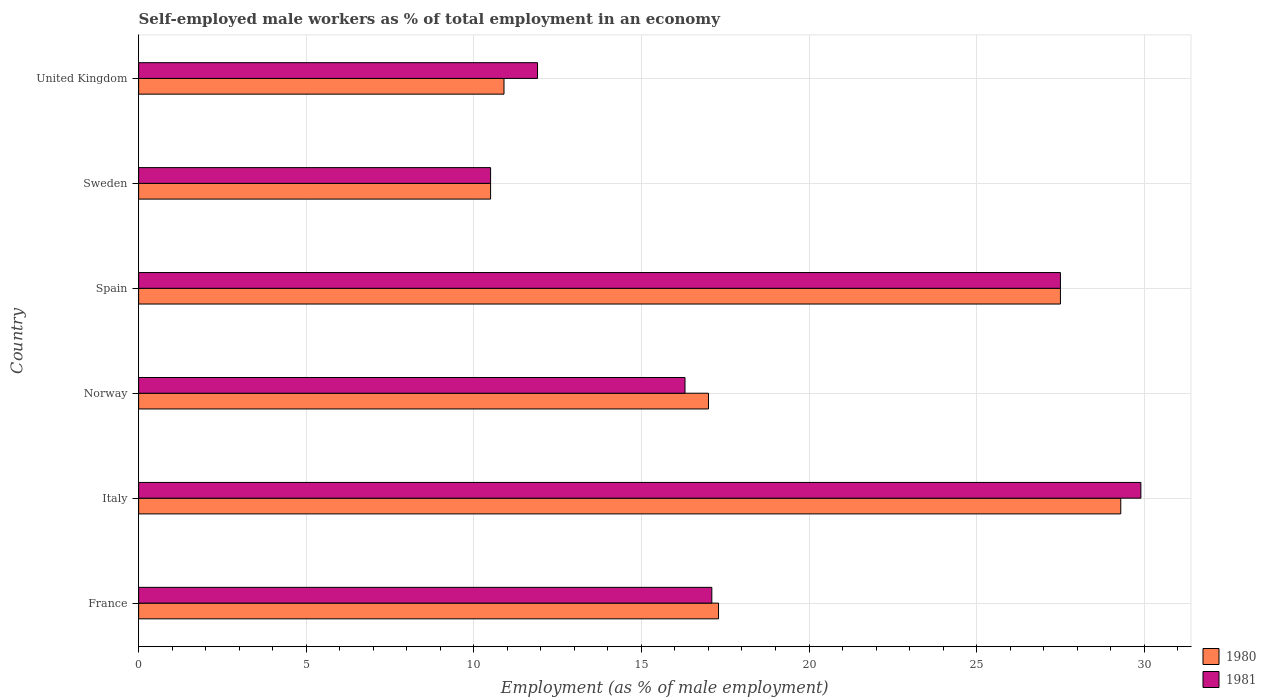How many different coloured bars are there?
Make the answer very short. 2. How many groups of bars are there?
Keep it short and to the point. 6. How many bars are there on the 5th tick from the top?
Keep it short and to the point. 2. What is the label of the 5th group of bars from the top?
Make the answer very short. Italy. What is the percentage of self-employed male workers in 1981 in Norway?
Offer a terse response. 16.3. Across all countries, what is the maximum percentage of self-employed male workers in 1980?
Your response must be concise. 29.3. In which country was the percentage of self-employed male workers in 1981 maximum?
Your answer should be very brief. Italy. What is the total percentage of self-employed male workers in 1980 in the graph?
Provide a succinct answer. 112.5. What is the difference between the percentage of self-employed male workers in 1980 in Norway and that in United Kingdom?
Offer a terse response. 6.1. What is the difference between the percentage of self-employed male workers in 1980 in Spain and the percentage of self-employed male workers in 1981 in France?
Give a very brief answer. 10.4. What is the average percentage of self-employed male workers in 1980 per country?
Provide a succinct answer. 18.75. What is the difference between the percentage of self-employed male workers in 1981 and percentage of self-employed male workers in 1980 in Spain?
Provide a succinct answer. 0. What is the ratio of the percentage of self-employed male workers in 1980 in France to that in Spain?
Offer a very short reply. 0.63. Is the difference between the percentage of self-employed male workers in 1981 in Norway and Sweden greater than the difference between the percentage of self-employed male workers in 1980 in Norway and Sweden?
Ensure brevity in your answer.  No. What is the difference between the highest and the second highest percentage of self-employed male workers in 1981?
Give a very brief answer. 2.4. What is the difference between the highest and the lowest percentage of self-employed male workers in 1981?
Provide a short and direct response. 19.4. Is the sum of the percentage of self-employed male workers in 1981 in Norway and Spain greater than the maximum percentage of self-employed male workers in 1980 across all countries?
Provide a short and direct response. Yes. What does the 1st bar from the bottom in Norway represents?
Your response must be concise. 1980. Are the values on the major ticks of X-axis written in scientific E-notation?
Your answer should be very brief. No. Does the graph contain grids?
Keep it short and to the point. Yes. How many legend labels are there?
Your answer should be very brief. 2. What is the title of the graph?
Your answer should be very brief. Self-employed male workers as % of total employment in an economy. What is the label or title of the X-axis?
Ensure brevity in your answer.  Employment (as % of male employment). What is the Employment (as % of male employment) of 1980 in France?
Provide a succinct answer. 17.3. What is the Employment (as % of male employment) of 1981 in France?
Your answer should be very brief. 17.1. What is the Employment (as % of male employment) in 1980 in Italy?
Give a very brief answer. 29.3. What is the Employment (as % of male employment) in 1981 in Italy?
Give a very brief answer. 29.9. What is the Employment (as % of male employment) in 1981 in Norway?
Offer a very short reply. 16.3. What is the Employment (as % of male employment) of 1980 in Spain?
Offer a terse response. 27.5. What is the Employment (as % of male employment) of 1981 in Spain?
Your response must be concise. 27.5. What is the Employment (as % of male employment) of 1981 in Sweden?
Your answer should be very brief. 10.5. What is the Employment (as % of male employment) in 1980 in United Kingdom?
Keep it short and to the point. 10.9. What is the Employment (as % of male employment) in 1981 in United Kingdom?
Offer a very short reply. 11.9. Across all countries, what is the maximum Employment (as % of male employment) of 1980?
Ensure brevity in your answer.  29.3. Across all countries, what is the maximum Employment (as % of male employment) of 1981?
Ensure brevity in your answer.  29.9. Across all countries, what is the minimum Employment (as % of male employment) in 1980?
Your response must be concise. 10.5. Across all countries, what is the minimum Employment (as % of male employment) of 1981?
Offer a terse response. 10.5. What is the total Employment (as % of male employment) of 1980 in the graph?
Your answer should be compact. 112.5. What is the total Employment (as % of male employment) of 1981 in the graph?
Provide a short and direct response. 113.2. What is the difference between the Employment (as % of male employment) of 1980 in France and that in Italy?
Ensure brevity in your answer.  -12. What is the difference between the Employment (as % of male employment) in 1981 in France and that in Italy?
Keep it short and to the point. -12.8. What is the difference between the Employment (as % of male employment) in 1980 in France and that in Norway?
Make the answer very short. 0.3. What is the difference between the Employment (as % of male employment) in 1981 in France and that in Norway?
Your answer should be compact. 0.8. What is the difference between the Employment (as % of male employment) of 1981 in France and that in Spain?
Offer a terse response. -10.4. What is the difference between the Employment (as % of male employment) in 1981 in France and that in United Kingdom?
Your answer should be very brief. 5.2. What is the difference between the Employment (as % of male employment) of 1981 in Italy and that in Norway?
Provide a succinct answer. 13.6. What is the difference between the Employment (as % of male employment) of 1980 in Italy and that in Spain?
Offer a terse response. 1.8. What is the difference between the Employment (as % of male employment) in 1981 in Italy and that in Spain?
Your answer should be compact. 2.4. What is the difference between the Employment (as % of male employment) in 1981 in Italy and that in Sweden?
Offer a terse response. 19.4. What is the difference between the Employment (as % of male employment) of 1980 in Italy and that in United Kingdom?
Provide a succinct answer. 18.4. What is the difference between the Employment (as % of male employment) in 1981 in Italy and that in United Kingdom?
Offer a terse response. 18. What is the difference between the Employment (as % of male employment) of 1981 in Norway and that in Spain?
Make the answer very short. -11.2. What is the difference between the Employment (as % of male employment) of 1980 in Norway and that in Sweden?
Your answer should be compact. 6.5. What is the difference between the Employment (as % of male employment) in 1981 in Norway and that in United Kingdom?
Make the answer very short. 4.4. What is the difference between the Employment (as % of male employment) of 1980 in Spain and that in United Kingdom?
Your response must be concise. 16.6. What is the difference between the Employment (as % of male employment) of 1980 in Sweden and that in United Kingdom?
Your answer should be compact. -0.4. What is the difference between the Employment (as % of male employment) in 1980 in France and the Employment (as % of male employment) in 1981 in Norway?
Your answer should be very brief. 1. What is the difference between the Employment (as % of male employment) in 1980 in France and the Employment (as % of male employment) in 1981 in Spain?
Offer a terse response. -10.2. What is the difference between the Employment (as % of male employment) of 1980 in Italy and the Employment (as % of male employment) of 1981 in Spain?
Keep it short and to the point. 1.8. What is the difference between the Employment (as % of male employment) in 1980 in Norway and the Employment (as % of male employment) in 1981 in Spain?
Offer a terse response. -10.5. What is the difference between the Employment (as % of male employment) in 1980 in Norway and the Employment (as % of male employment) in 1981 in Sweden?
Provide a short and direct response. 6.5. What is the difference between the Employment (as % of male employment) of 1980 in Norway and the Employment (as % of male employment) of 1981 in United Kingdom?
Make the answer very short. 5.1. What is the difference between the Employment (as % of male employment) in 1980 in Spain and the Employment (as % of male employment) in 1981 in Sweden?
Make the answer very short. 17. What is the difference between the Employment (as % of male employment) in 1980 in Spain and the Employment (as % of male employment) in 1981 in United Kingdom?
Make the answer very short. 15.6. What is the difference between the Employment (as % of male employment) in 1980 in Sweden and the Employment (as % of male employment) in 1981 in United Kingdom?
Offer a very short reply. -1.4. What is the average Employment (as % of male employment) of 1980 per country?
Your answer should be compact. 18.75. What is the average Employment (as % of male employment) in 1981 per country?
Provide a short and direct response. 18.87. What is the difference between the Employment (as % of male employment) of 1980 and Employment (as % of male employment) of 1981 in Norway?
Your response must be concise. 0.7. What is the difference between the Employment (as % of male employment) in 1980 and Employment (as % of male employment) in 1981 in Sweden?
Provide a succinct answer. 0. What is the difference between the Employment (as % of male employment) of 1980 and Employment (as % of male employment) of 1981 in United Kingdom?
Ensure brevity in your answer.  -1. What is the ratio of the Employment (as % of male employment) of 1980 in France to that in Italy?
Your response must be concise. 0.59. What is the ratio of the Employment (as % of male employment) in 1981 in France to that in Italy?
Your response must be concise. 0.57. What is the ratio of the Employment (as % of male employment) of 1980 in France to that in Norway?
Your response must be concise. 1.02. What is the ratio of the Employment (as % of male employment) in 1981 in France to that in Norway?
Make the answer very short. 1.05. What is the ratio of the Employment (as % of male employment) of 1980 in France to that in Spain?
Offer a very short reply. 0.63. What is the ratio of the Employment (as % of male employment) in 1981 in France to that in Spain?
Your answer should be very brief. 0.62. What is the ratio of the Employment (as % of male employment) of 1980 in France to that in Sweden?
Offer a very short reply. 1.65. What is the ratio of the Employment (as % of male employment) of 1981 in France to that in Sweden?
Your answer should be very brief. 1.63. What is the ratio of the Employment (as % of male employment) in 1980 in France to that in United Kingdom?
Make the answer very short. 1.59. What is the ratio of the Employment (as % of male employment) of 1981 in France to that in United Kingdom?
Your answer should be compact. 1.44. What is the ratio of the Employment (as % of male employment) of 1980 in Italy to that in Norway?
Offer a very short reply. 1.72. What is the ratio of the Employment (as % of male employment) of 1981 in Italy to that in Norway?
Ensure brevity in your answer.  1.83. What is the ratio of the Employment (as % of male employment) in 1980 in Italy to that in Spain?
Ensure brevity in your answer.  1.07. What is the ratio of the Employment (as % of male employment) of 1981 in Italy to that in Spain?
Keep it short and to the point. 1.09. What is the ratio of the Employment (as % of male employment) in 1980 in Italy to that in Sweden?
Your response must be concise. 2.79. What is the ratio of the Employment (as % of male employment) in 1981 in Italy to that in Sweden?
Your answer should be very brief. 2.85. What is the ratio of the Employment (as % of male employment) in 1980 in Italy to that in United Kingdom?
Make the answer very short. 2.69. What is the ratio of the Employment (as % of male employment) of 1981 in Italy to that in United Kingdom?
Make the answer very short. 2.51. What is the ratio of the Employment (as % of male employment) of 1980 in Norway to that in Spain?
Provide a short and direct response. 0.62. What is the ratio of the Employment (as % of male employment) in 1981 in Norway to that in Spain?
Ensure brevity in your answer.  0.59. What is the ratio of the Employment (as % of male employment) of 1980 in Norway to that in Sweden?
Your answer should be compact. 1.62. What is the ratio of the Employment (as % of male employment) in 1981 in Norway to that in Sweden?
Your response must be concise. 1.55. What is the ratio of the Employment (as % of male employment) of 1980 in Norway to that in United Kingdom?
Provide a short and direct response. 1.56. What is the ratio of the Employment (as % of male employment) in 1981 in Norway to that in United Kingdom?
Your answer should be very brief. 1.37. What is the ratio of the Employment (as % of male employment) of 1980 in Spain to that in Sweden?
Your answer should be compact. 2.62. What is the ratio of the Employment (as % of male employment) of 1981 in Spain to that in Sweden?
Give a very brief answer. 2.62. What is the ratio of the Employment (as % of male employment) in 1980 in Spain to that in United Kingdom?
Provide a succinct answer. 2.52. What is the ratio of the Employment (as % of male employment) of 1981 in Spain to that in United Kingdom?
Offer a terse response. 2.31. What is the ratio of the Employment (as % of male employment) in 1980 in Sweden to that in United Kingdom?
Your answer should be compact. 0.96. What is the ratio of the Employment (as % of male employment) of 1981 in Sweden to that in United Kingdom?
Ensure brevity in your answer.  0.88. What is the difference between the highest and the second highest Employment (as % of male employment) in 1980?
Your response must be concise. 1.8. What is the difference between the highest and the lowest Employment (as % of male employment) in 1980?
Provide a short and direct response. 18.8. 